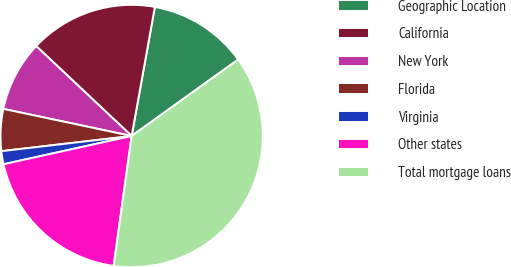<chart> <loc_0><loc_0><loc_500><loc_500><pie_chart><fcel>Geographic Location<fcel>California<fcel>New York<fcel>Florida<fcel>Virginia<fcel>Other states<fcel>Total mortgage loans<nl><fcel>12.26%<fcel>15.81%<fcel>8.71%<fcel>5.16%<fcel>1.61%<fcel>19.36%<fcel>37.1%<nl></chart> 